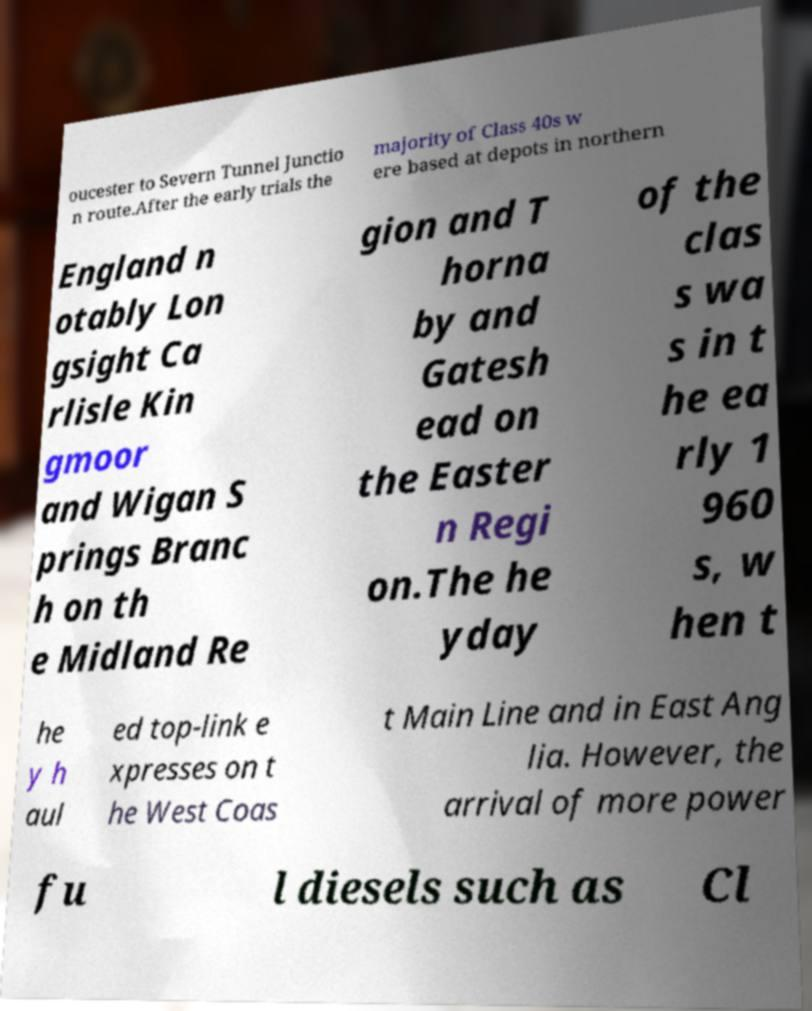There's text embedded in this image that I need extracted. Can you transcribe it verbatim? oucester to Severn Tunnel Junctio n route.After the early trials the majority of Class 40s w ere based at depots in northern England n otably Lon gsight Ca rlisle Kin gmoor and Wigan S prings Branc h on th e Midland Re gion and T horna by and Gatesh ead on the Easter n Regi on.The he yday of the clas s wa s in t he ea rly 1 960 s, w hen t he y h aul ed top-link e xpresses on t he West Coas t Main Line and in East Ang lia. However, the arrival of more power fu l diesels such as Cl 